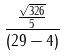<formula> <loc_0><loc_0><loc_500><loc_500>\frac { \frac { \sqrt { 3 2 6 } } { 5 } } { ( 2 9 - 4 ) }</formula> 